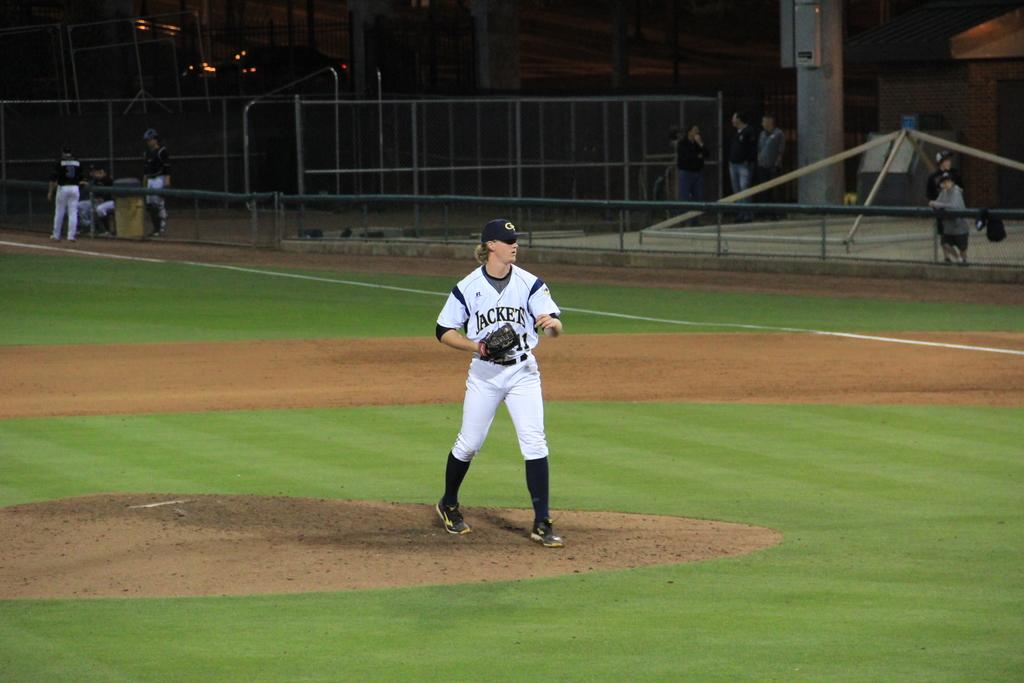Provide a one-sentence caption for the provided image. A pitcher for the Jackets on the pitcher's mound during a game. 